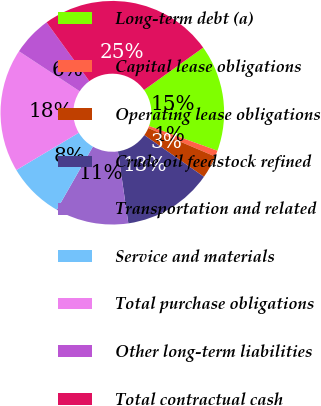<chart> <loc_0><loc_0><loc_500><loc_500><pie_chart><fcel>Long-term debt (a)<fcel>Capital lease obligations<fcel>Operating lease obligations<fcel>Crude oil feedstock refined<fcel>Transportation and related<fcel>Service and materials<fcel>Total purchase obligations<fcel>Other long-term liabilities<fcel>Total contractual cash<nl><fcel>15.42%<fcel>0.88%<fcel>3.31%<fcel>13.0%<fcel>10.57%<fcel>8.15%<fcel>17.84%<fcel>5.73%<fcel>25.11%<nl></chart> 